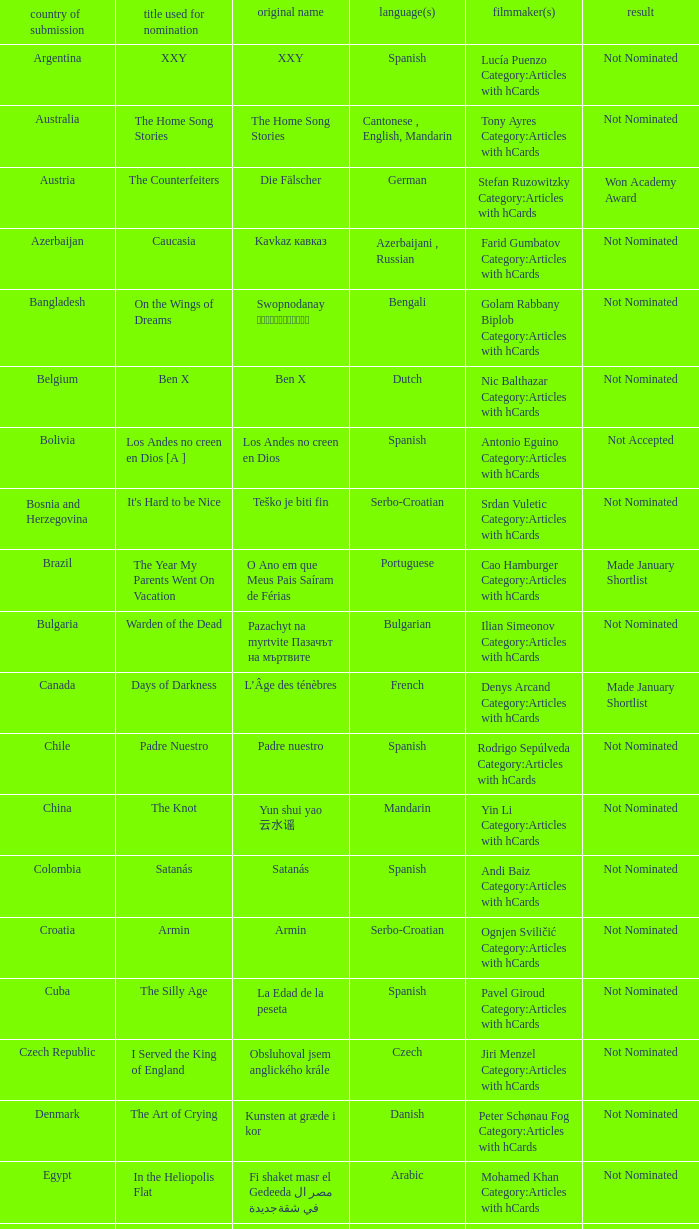What country submitted the movie the orphanage? Spain. 